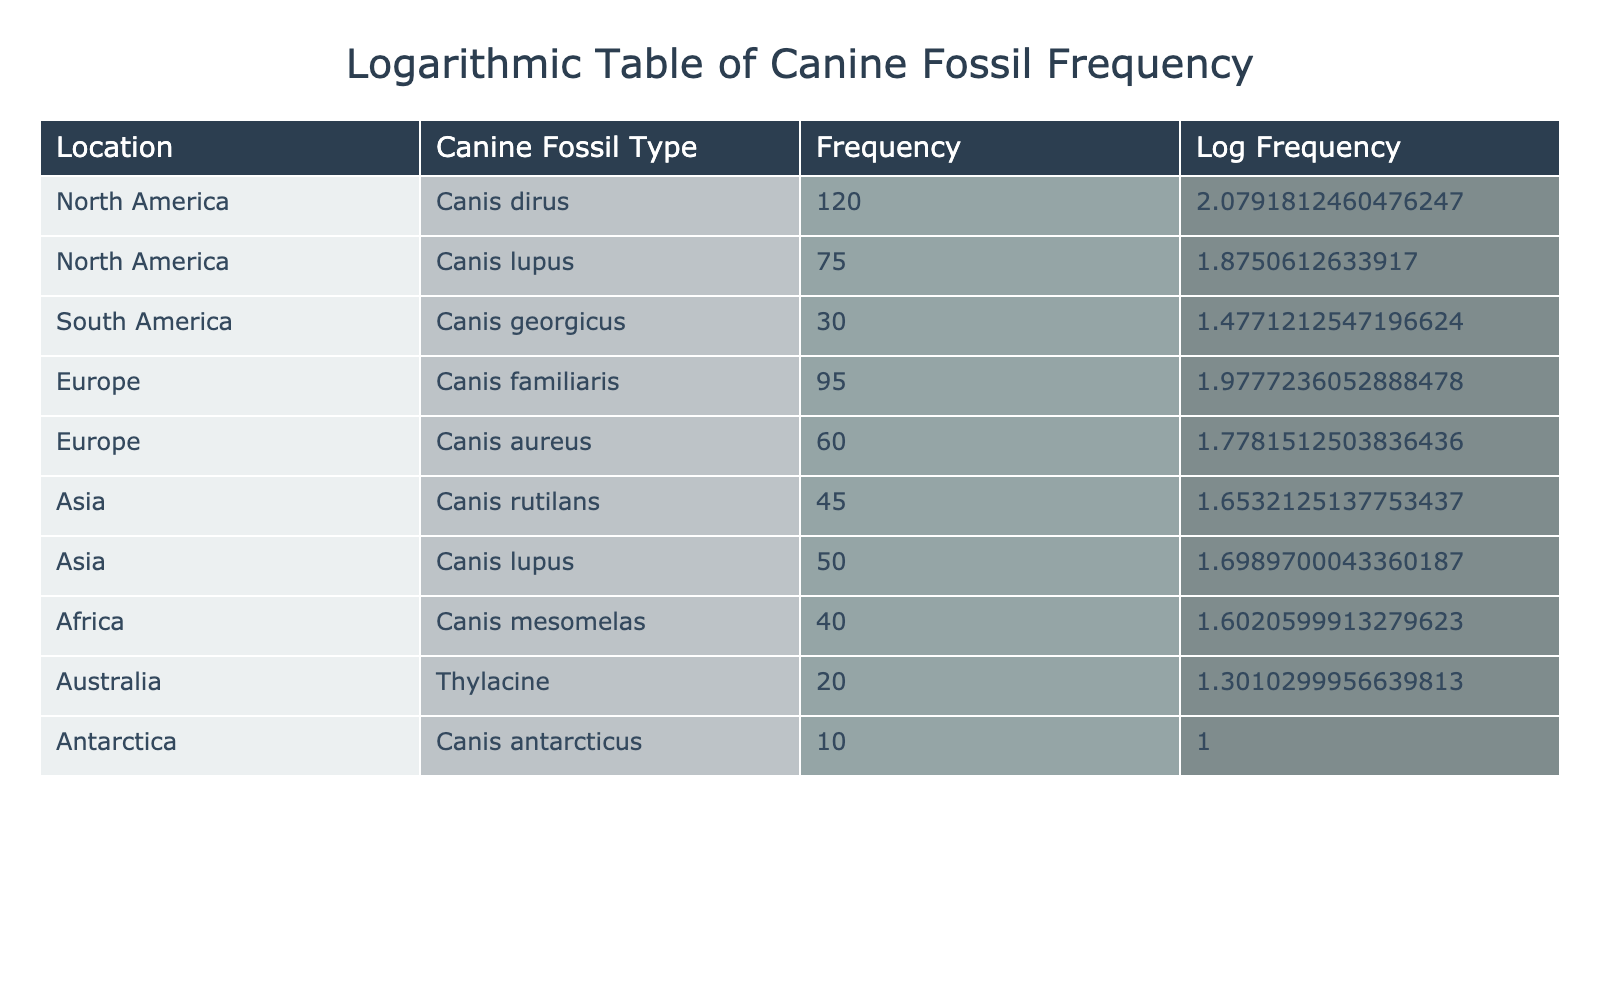What is the frequency of Canis dirus in North America? The frequency of Canis dirus is directly listed under the North America row in the table, which shows a value of 120.
Answer: 120 Which canine fossil type has the highest frequency overall? To find the highest frequency, I need to compare all the frequencies listed in the table: 120 (Canis dirus), 75 (Canis lupus), 30 (Canis georgicus), 95 (Canis familiaris), 60 (Canis aureus), 45 (Canis rutilans), 50 (Canis lupus), 40 (Canis mesomelas), 20 (Thylacine), and 10 (Canis antarcticus). The highest value is 120 for Canis dirus.
Answer: Canis dirus Is there a canine fossil type found in Antarctica? The table shows a row for Canis antarcticus located in Antarctica with a frequency of 10, thus confirming a fossil type from this location.
Answer: Yes What is the total frequency of canine fossil types in Europe? Summing the frequencies for Europe: Canis familiaris (95) + Canis aureus (60) gives a total of 155. Therefore, the total frequency of canine fossil types found in Europe is 155.
Answer: 155 Which location has the lowest frequency of canine fossils? To find the lowest frequency, I review the frequencies from each location: North America (120, 75), South America (30), Europe (95, 60), Asia (45, 50), Africa (40), Australia (20), Antarctica (10). The lowest value is 10 for Antarctica.
Answer: Antarctica What is the average frequency of canine fossil types in Asia? There are two entries for Asia: Canis rutilans (45) and Canis lupus (50). The total frequency is 45 + 50 = 95, with 2 entries. The average is 95/2 = 47.5.
Answer: 47.5 Is Canis mesomelas found in Asia? The table lists Canis mesomelas under Africa with a frequency of 40, therefore it is not found in Asia.
Answer: No What is the difference in frequency between the highest and lowest fossil types from the total data? The highest frequency is 120 (Canis dirus), and the lowest is 10 (Canis antarcticus). The difference is 120 - 10 = 110.
Answer: 110 